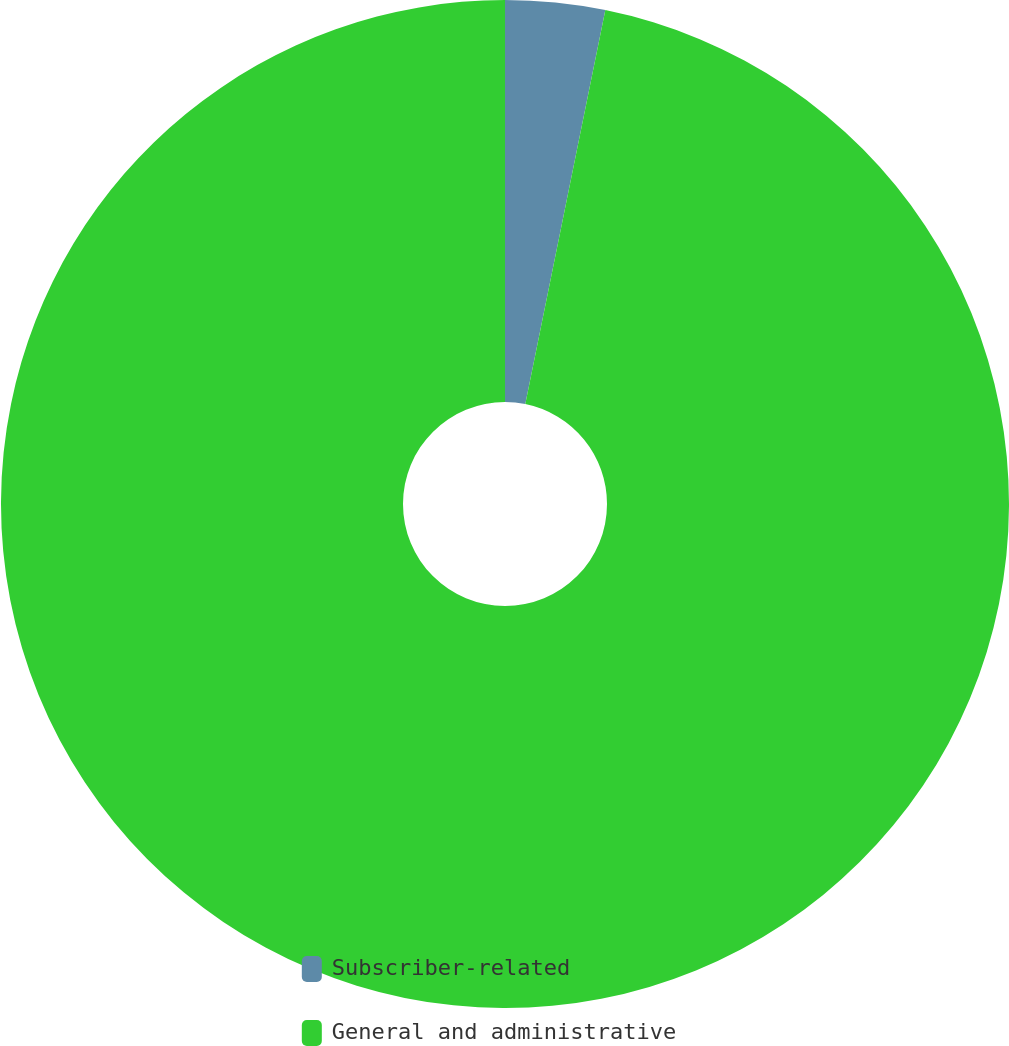<chart> <loc_0><loc_0><loc_500><loc_500><pie_chart><fcel>Subscriber-related<fcel>General and administrative<nl><fcel>3.19%<fcel>96.81%<nl></chart> 